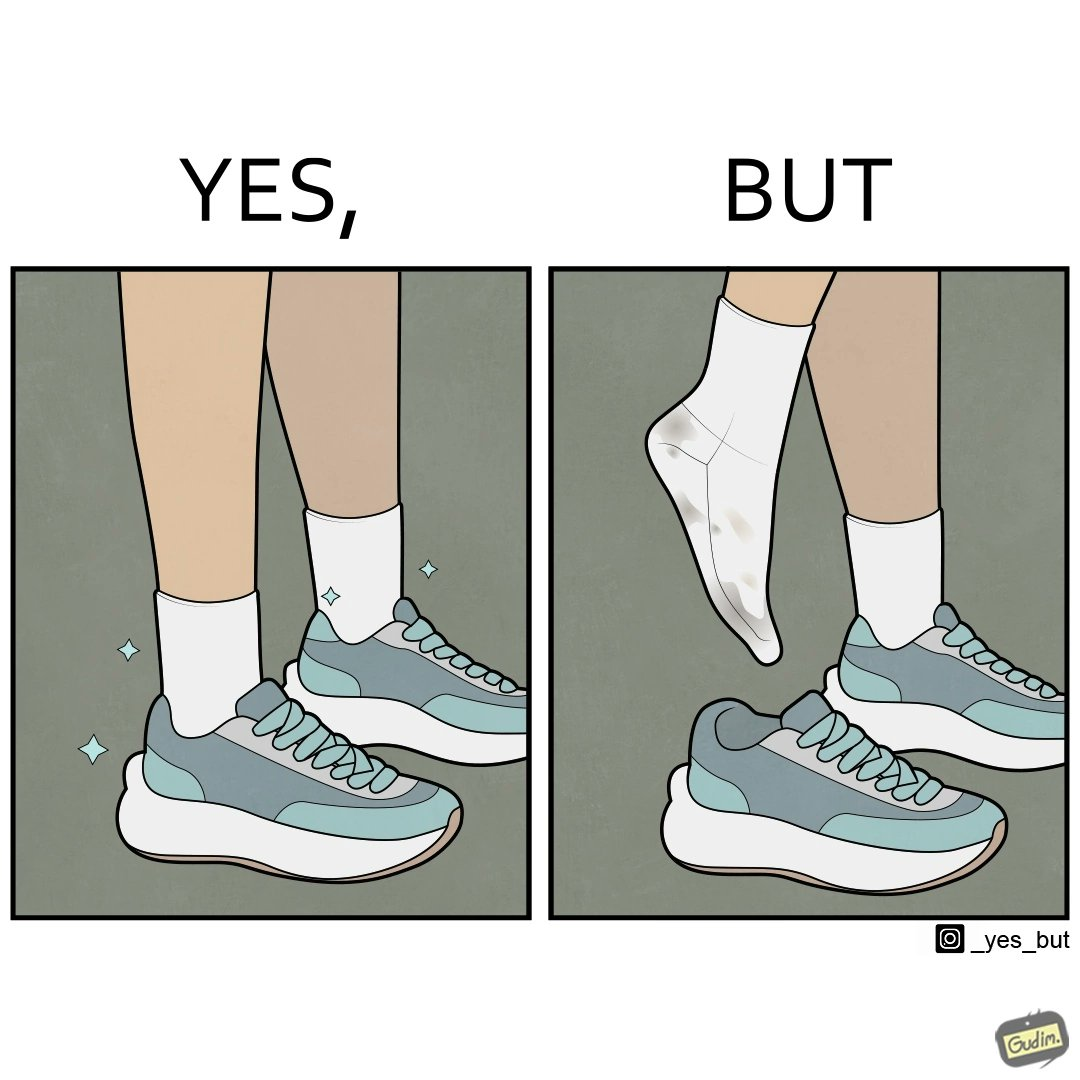What does this image depict? The person's shocks is very dirty although the shoes are very clean. Thus there is an irony that not all things are same as they appear. 